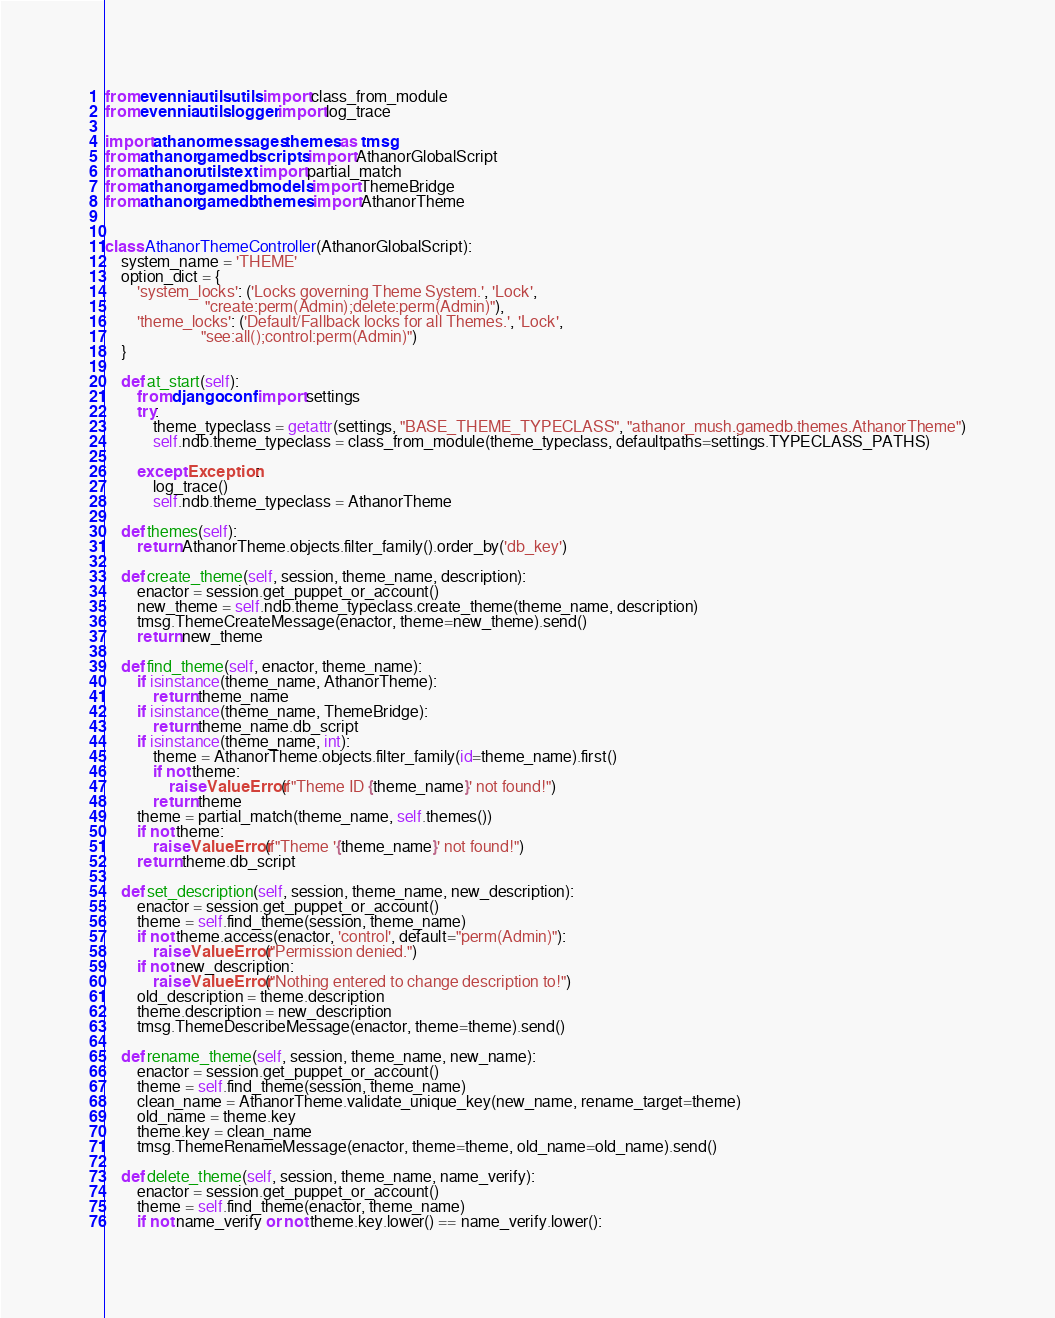<code> <loc_0><loc_0><loc_500><loc_500><_Python_>from evennia.utils.utils import class_from_module
from evennia.utils.logger import log_trace

import athanor.messages.themes as tmsg
from athanor.gamedb.scripts import AthanorGlobalScript
from athanor.utils.text import partial_match
from athanor.gamedb.models import ThemeBridge
from athanor.gamedb.themes import AthanorTheme


class AthanorThemeController(AthanorGlobalScript):
    system_name = 'THEME'
    option_dict = {
        'system_locks': ('Locks governing Theme System.', 'Lock',
                         "create:perm(Admin);delete:perm(Admin)"),
        'theme_locks': ('Default/Fallback locks for all Themes.', 'Lock',
                        "see:all();control:perm(Admin)")
    }

    def at_start(self):
        from django.conf import settings
        try:
            theme_typeclass = getattr(settings, "BASE_THEME_TYPECLASS", "athanor_mush.gamedb.themes.AthanorTheme")
            self.ndb.theme_typeclass = class_from_module(theme_typeclass, defaultpaths=settings.TYPECLASS_PATHS)

        except Exception:
            log_trace()
            self.ndb.theme_typeclass = AthanorTheme

    def themes(self):
        return AthanorTheme.objects.filter_family().order_by('db_key')

    def create_theme(self, session, theme_name, description):
        enactor = session.get_puppet_or_account()
        new_theme = self.ndb.theme_typeclass.create_theme(theme_name, description)
        tmsg.ThemeCreateMessage(enactor, theme=new_theme).send()
        return new_theme

    def find_theme(self, enactor, theme_name):
        if isinstance(theme_name, AthanorTheme):
            return theme_name
        if isinstance(theme_name, ThemeBridge):
            return theme_name.db_script
        if isinstance(theme_name, int):
            theme = AthanorTheme.objects.filter_family(id=theme_name).first()
            if not theme:
                raise ValueError(f"Theme ID {theme_name}' not found!")
            return theme
        theme = partial_match(theme_name, self.themes())
        if not theme:
            raise ValueError(f"Theme '{theme_name}' not found!")
        return theme.db_script

    def set_description(self, session, theme_name, new_description):
        enactor = session.get_puppet_or_account()
        theme = self.find_theme(session, theme_name)
        if not theme.access(enactor, 'control', default="perm(Admin)"):
            raise ValueError("Permission denied.")
        if not new_description:
            raise ValueError("Nothing entered to change description to!")
        old_description = theme.description
        theme.description = new_description
        tmsg.ThemeDescribeMessage(enactor, theme=theme).send()

    def rename_theme(self, session, theme_name, new_name):
        enactor = session.get_puppet_or_account()
        theme = self.find_theme(session, theme_name)
        clean_name = AthanorTheme.validate_unique_key(new_name, rename_target=theme)
        old_name = theme.key
        theme.key = clean_name
        tmsg.ThemeRenameMessage(enactor, theme=theme, old_name=old_name).send()

    def delete_theme(self, session, theme_name, name_verify):
        enactor = session.get_puppet_or_account()
        theme = self.find_theme(enactor, theme_name)
        if not name_verify or not theme.key.lower() == name_verify.lower():</code> 